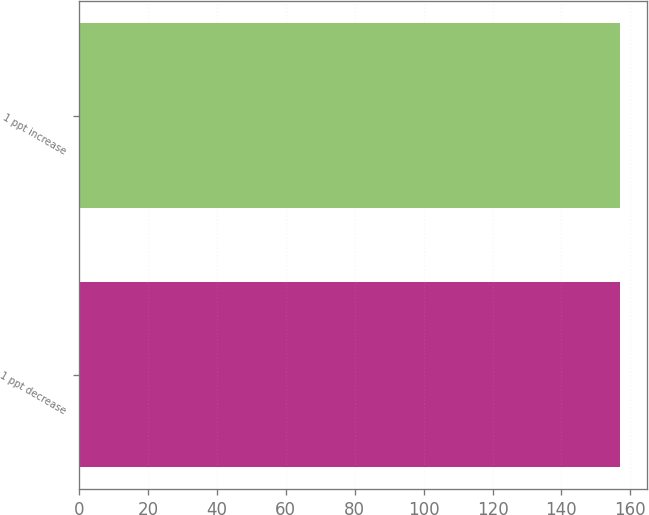<chart> <loc_0><loc_0><loc_500><loc_500><bar_chart><fcel>1 ppt decrease<fcel>1 ppt increase<nl><fcel>157<fcel>157.1<nl></chart> 